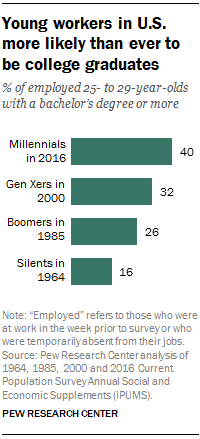Specify some key components in this picture. The sum of the median and largest bar is 69. 